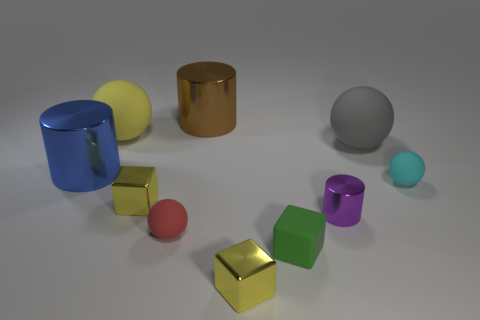How many other objects are the same color as the rubber cube?
Provide a short and direct response. 0. Do the large metal thing that is to the right of the large yellow thing and the small purple metal object right of the brown metallic cylinder have the same shape?
Keep it short and to the point. Yes. What number of objects are yellow things in front of the tiny cyan sphere or large metallic cylinders on the left side of the green rubber cube?
Offer a terse response. 4. What number of other things are the same material as the yellow ball?
Provide a short and direct response. 4. Is the big ball on the right side of the tiny matte cube made of the same material as the small cyan thing?
Your response must be concise. Yes. Are there more large yellow things left of the large brown thing than blue objects that are to the right of the small purple metal object?
Make the answer very short. Yes. How many objects are tiny red objects that are in front of the big blue metal cylinder or yellow metallic cubes?
Your answer should be compact. 3. What shape is the large blue object that is made of the same material as the purple thing?
Your answer should be very brief. Cylinder. Is there any other thing that is the same shape as the brown object?
Provide a short and direct response. Yes. There is a small matte thing that is both behind the small green matte thing and on the left side of the large gray sphere; what is its color?
Provide a short and direct response. Red. 